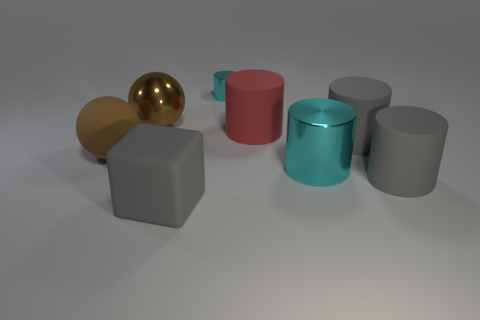Do the red cylinder and the cyan cylinder that is behind the big brown rubber thing have the same material?
Offer a terse response. No. There is another metallic cylinder that is the same color as the small metal cylinder; what size is it?
Offer a terse response. Large. Are there any big gray objects made of the same material as the large cyan cylinder?
Provide a short and direct response. No. How many things are either gray rubber blocks to the right of the large brown matte thing or matte cylinders that are behind the big cyan thing?
Give a very brief answer. 3. There is a big red object; does it have the same shape as the big brown thing in front of the big red cylinder?
Give a very brief answer. No. What number of other objects are the same shape as the large red matte object?
Give a very brief answer. 4. How many objects are either tiny shiny cylinders or tiny brown blocks?
Keep it short and to the point. 1. Is the color of the tiny metal object the same as the big metallic cylinder?
Your answer should be very brief. Yes. Is there anything else that is the same size as the gray block?
Offer a very short reply. Yes. What shape is the cyan object that is in front of the metal cylinder that is behind the large brown metallic thing?
Give a very brief answer. Cylinder. 